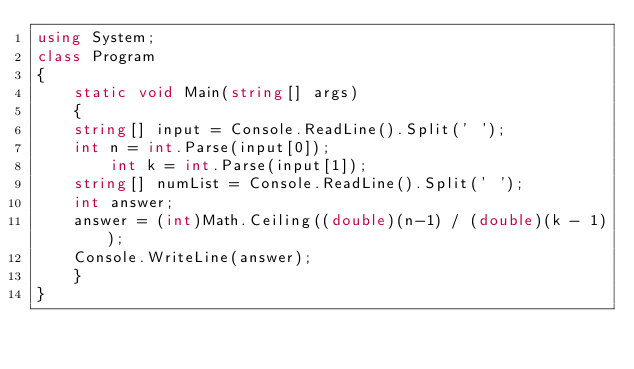Convert code to text. <code><loc_0><loc_0><loc_500><loc_500><_C#_>using System;
class Program
{
    static void Main(string[] args)
    {
		string[] input = Console.ReadLine().Split(' ');
		int n = int.Parse(input[0]);
        int k = int.Parse(input[1]);     
		string[] numList = Console.ReadLine().Split(' ');
		int answer;
		answer = (int)Math.Ceiling((double)(n-1) / (double)(k - 1));
		Console.WriteLine(answer);
    }
}
</code> 